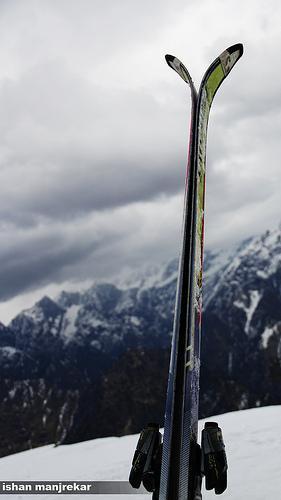How many ski boards on the snow?
Give a very brief answer. 2. 